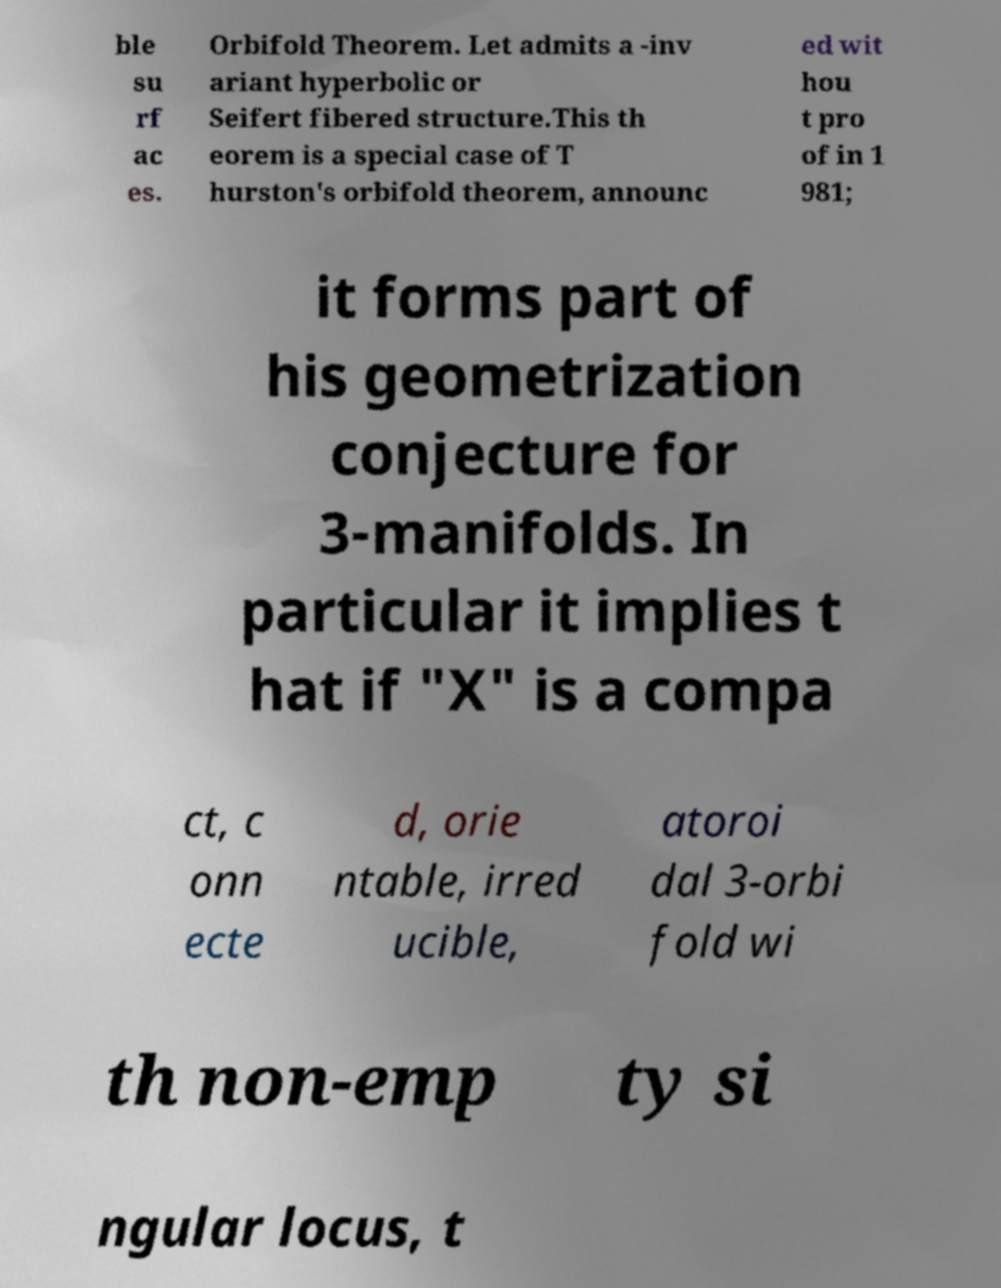Could you assist in decoding the text presented in this image and type it out clearly? ble su rf ac es. Orbifold Theorem. Let admits a -inv ariant hyperbolic or Seifert fibered structure.This th eorem is a special case of T hurston's orbifold theorem, announc ed wit hou t pro of in 1 981; it forms part of his geometrization conjecture for 3-manifolds. In particular it implies t hat if "X" is a compa ct, c onn ecte d, orie ntable, irred ucible, atoroi dal 3-orbi fold wi th non-emp ty si ngular locus, t 